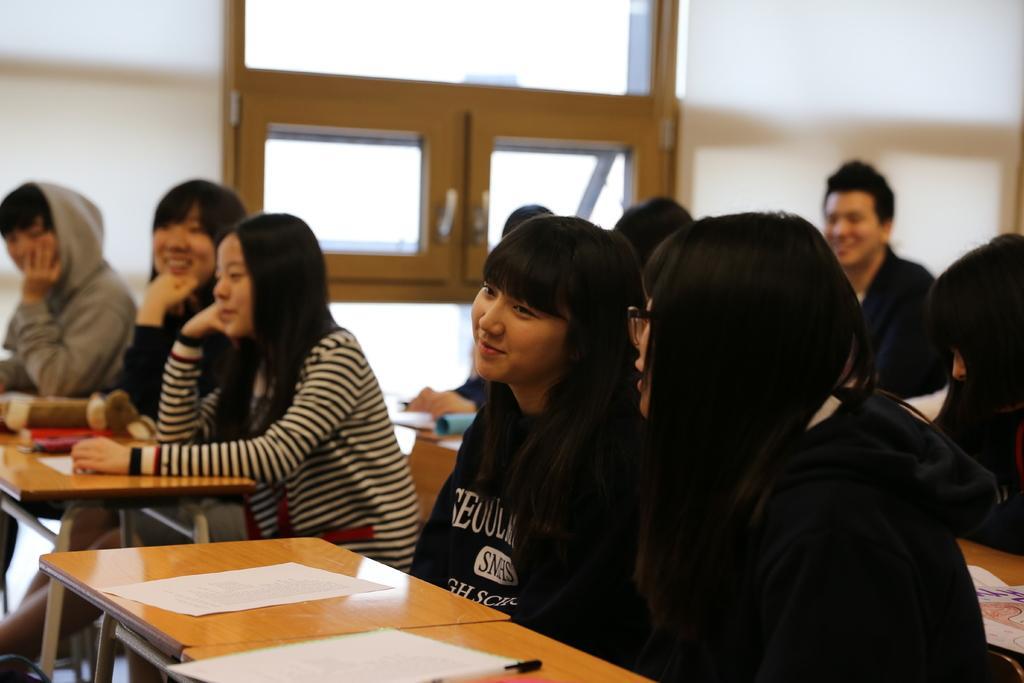Please provide a concise description of this image. In this image I can see number of people are sitting on benches. I can also see smile on few faces. Here. I can see few papers. 